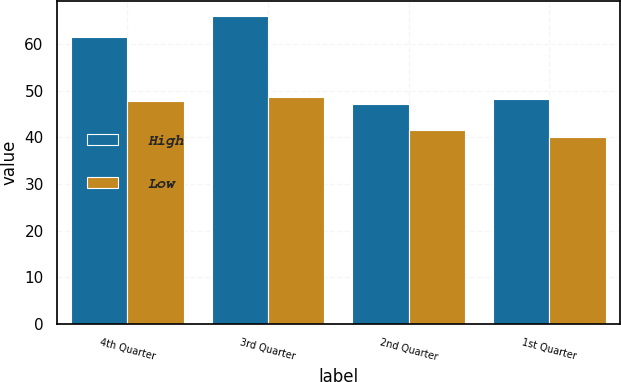<chart> <loc_0><loc_0><loc_500><loc_500><stacked_bar_chart><ecel><fcel>4th Quarter<fcel>3rd Quarter<fcel>2nd Quarter<fcel>1st Quarter<nl><fcel>High<fcel>61.55<fcel>65.89<fcel>47.16<fcel>48.14<nl><fcel>Low<fcel>47.76<fcel>48.64<fcel>41.49<fcel>39.97<nl></chart> 